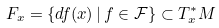Convert formula to latex. <formula><loc_0><loc_0><loc_500><loc_500>F _ { x } = \{ d f ( x ) \, | \, f \in \mathcal { F } \} \subset T _ { x } ^ { * } M</formula> 